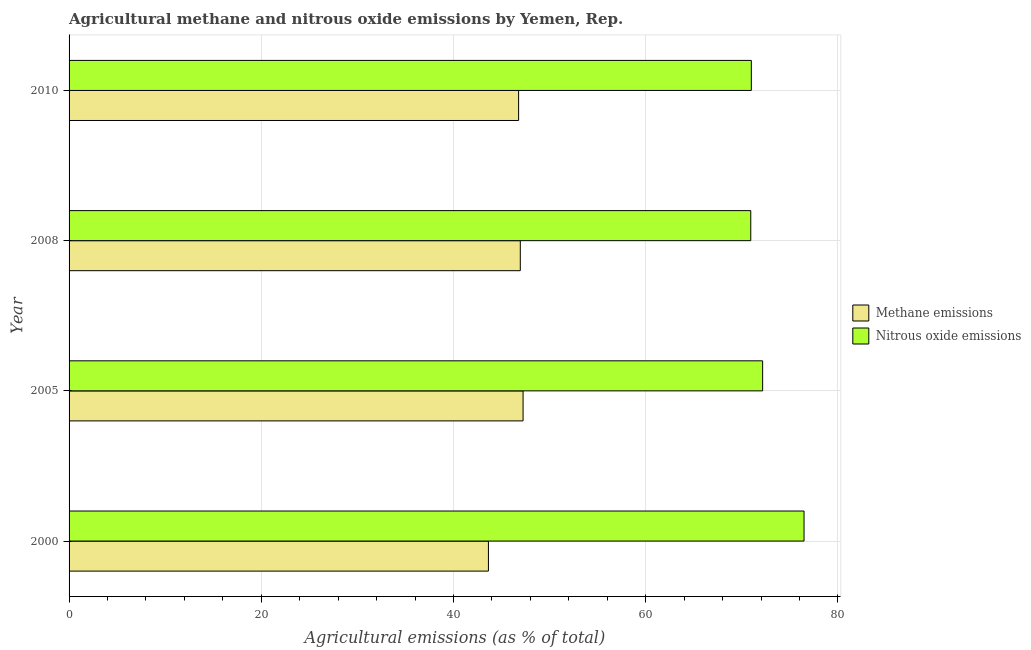How many different coloured bars are there?
Offer a very short reply. 2. Are the number of bars per tick equal to the number of legend labels?
Give a very brief answer. Yes. Are the number of bars on each tick of the Y-axis equal?
Your response must be concise. Yes. How many bars are there on the 2nd tick from the top?
Offer a very short reply. 2. What is the label of the 4th group of bars from the top?
Offer a very short reply. 2000. What is the amount of nitrous oxide emissions in 2000?
Your answer should be very brief. 76.48. Across all years, what is the maximum amount of nitrous oxide emissions?
Ensure brevity in your answer.  76.48. Across all years, what is the minimum amount of methane emissions?
Ensure brevity in your answer.  43.64. What is the total amount of nitrous oxide emissions in the graph?
Make the answer very short. 290.58. What is the difference between the amount of methane emissions in 2005 and that in 2008?
Provide a succinct answer. 0.29. What is the difference between the amount of nitrous oxide emissions in 2000 and the amount of methane emissions in 2005?
Your response must be concise. 29.24. What is the average amount of methane emissions per year?
Provide a short and direct response. 46.15. In the year 2010, what is the difference between the amount of methane emissions and amount of nitrous oxide emissions?
Your response must be concise. -24.22. What is the ratio of the amount of nitrous oxide emissions in 2000 to that in 2008?
Offer a very short reply. 1.08. Is the amount of methane emissions in 2008 less than that in 2010?
Offer a very short reply. No. Is the difference between the amount of methane emissions in 2008 and 2010 greater than the difference between the amount of nitrous oxide emissions in 2008 and 2010?
Make the answer very short. Yes. What is the difference between the highest and the second highest amount of nitrous oxide emissions?
Keep it short and to the point. 4.31. What is the difference between the highest and the lowest amount of nitrous oxide emissions?
Give a very brief answer. 5.54. What does the 2nd bar from the top in 2005 represents?
Provide a succinct answer. Methane emissions. What does the 2nd bar from the bottom in 2008 represents?
Ensure brevity in your answer.  Nitrous oxide emissions. How many bars are there?
Make the answer very short. 8. Are all the bars in the graph horizontal?
Your response must be concise. Yes. How many years are there in the graph?
Give a very brief answer. 4. Does the graph contain any zero values?
Keep it short and to the point. No. Where does the legend appear in the graph?
Provide a short and direct response. Center right. How many legend labels are there?
Offer a very short reply. 2. What is the title of the graph?
Ensure brevity in your answer.  Agricultural methane and nitrous oxide emissions by Yemen, Rep. What is the label or title of the X-axis?
Your response must be concise. Agricultural emissions (as % of total). What is the label or title of the Y-axis?
Offer a terse response. Year. What is the Agricultural emissions (as % of total) of Methane emissions in 2000?
Keep it short and to the point. 43.64. What is the Agricultural emissions (as % of total) of Nitrous oxide emissions in 2000?
Ensure brevity in your answer.  76.48. What is the Agricultural emissions (as % of total) in Methane emissions in 2005?
Provide a succinct answer. 47.24. What is the Agricultural emissions (as % of total) of Nitrous oxide emissions in 2005?
Give a very brief answer. 72.17. What is the Agricultural emissions (as % of total) of Methane emissions in 2008?
Give a very brief answer. 46.95. What is the Agricultural emissions (as % of total) of Nitrous oxide emissions in 2008?
Provide a succinct answer. 70.93. What is the Agricultural emissions (as % of total) of Methane emissions in 2010?
Ensure brevity in your answer.  46.78. What is the Agricultural emissions (as % of total) in Nitrous oxide emissions in 2010?
Provide a short and direct response. 70.99. Across all years, what is the maximum Agricultural emissions (as % of total) of Methane emissions?
Your response must be concise. 47.24. Across all years, what is the maximum Agricultural emissions (as % of total) of Nitrous oxide emissions?
Offer a very short reply. 76.48. Across all years, what is the minimum Agricultural emissions (as % of total) of Methane emissions?
Provide a succinct answer. 43.64. Across all years, what is the minimum Agricultural emissions (as % of total) of Nitrous oxide emissions?
Offer a very short reply. 70.93. What is the total Agricultural emissions (as % of total) in Methane emissions in the graph?
Keep it short and to the point. 184.61. What is the total Agricultural emissions (as % of total) of Nitrous oxide emissions in the graph?
Offer a very short reply. 290.58. What is the difference between the Agricultural emissions (as % of total) of Methane emissions in 2000 and that in 2005?
Offer a very short reply. -3.61. What is the difference between the Agricultural emissions (as % of total) in Nitrous oxide emissions in 2000 and that in 2005?
Your answer should be very brief. 4.31. What is the difference between the Agricultural emissions (as % of total) of Methane emissions in 2000 and that in 2008?
Ensure brevity in your answer.  -3.32. What is the difference between the Agricultural emissions (as % of total) of Nitrous oxide emissions in 2000 and that in 2008?
Your response must be concise. 5.54. What is the difference between the Agricultural emissions (as % of total) in Methane emissions in 2000 and that in 2010?
Your answer should be compact. -3.14. What is the difference between the Agricultural emissions (as % of total) in Nitrous oxide emissions in 2000 and that in 2010?
Ensure brevity in your answer.  5.49. What is the difference between the Agricultural emissions (as % of total) in Methane emissions in 2005 and that in 2008?
Your response must be concise. 0.29. What is the difference between the Agricultural emissions (as % of total) in Nitrous oxide emissions in 2005 and that in 2008?
Make the answer very short. 1.24. What is the difference between the Agricultural emissions (as % of total) in Methane emissions in 2005 and that in 2010?
Make the answer very short. 0.46. What is the difference between the Agricultural emissions (as % of total) in Nitrous oxide emissions in 2005 and that in 2010?
Your answer should be compact. 1.18. What is the difference between the Agricultural emissions (as % of total) of Methane emissions in 2008 and that in 2010?
Give a very brief answer. 0.18. What is the difference between the Agricultural emissions (as % of total) of Nitrous oxide emissions in 2008 and that in 2010?
Your answer should be very brief. -0.06. What is the difference between the Agricultural emissions (as % of total) in Methane emissions in 2000 and the Agricultural emissions (as % of total) in Nitrous oxide emissions in 2005?
Offer a terse response. -28.53. What is the difference between the Agricultural emissions (as % of total) in Methane emissions in 2000 and the Agricultural emissions (as % of total) in Nitrous oxide emissions in 2008?
Your response must be concise. -27.3. What is the difference between the Agricultural emissions (as % of total) of Methane emissions in 2000 and the Agricultural emissions (as % of total) of Nitrous oxide emissions in 2010?
Provide a succinct answer. -27.36. What is the difference between the Agricultural emissions (as % of total) of Methane emissions in 2005 and the Agricultural emissions (as % of total) of Nitrous oxide emissions in 2008?
Your response must be concise. -23.69. What is the difference between the Agricultural emissions (as % of total) of Methane emissions in 2005 and the Agricultural emissions (as % of total) of Nitrous oxide emissions in 2010?
Make the answer very short. -23.75. What is the difference between the Agricultural emissions (as % of total) in Methane emissions in 2008 and the Agricultural emissions (as % of total) in Nitrous oxide emissions in 2010?
Provide a short and direct response. -24.04. What is the average Agricultural emissions (as % of total) in Methane emissions per year?
Provide a short and direct response. 46.15. What is the average Agricultural emissions (as % of total) in Nitrous oxide emissions per year?
Give a very brief answer. 72.64. In the year 2000, what is the difference between the Agricultural emissions (as % of total) in Methane emissions and Agricultural emissions (as % of total) in Nitrous oxide emissions?
Provide a succinct answer. -32.84. In the year 2005, what is the difference between the Agricultural emissions (as % of total) in Methane emissions and Agricultural emissions (as % of total) in Nitrous oxide emissions?
Your answer should be compact. -24.93. In the year 2008, what is the difference between the Agricultural emissions (as % of total) of Methane emissions and Agricultural emissions (as % of total) of Nitrous oxide emissions?
Provide a short and direct response. -23.98. In the year 2010, what is the difference between the Agricultural emissions (as % of total) in Methane emissions and Agricultural emissions (as % of total) in Nitrous oxide emissions?
Your answer should be compact. -24.22. What is the ratio of the Agricultural emissions (as % of total) in Methane emissions in 2000 to that in 2005?
Provide a succinct answer. 0.92. What is the ratio of the Agricultural emissions (as % of total) in Nitrous oxide emissions in 2000 to that in 2005?
Ensure brevity in your answer.  1.06. What is the ratio of the Agricultural emissions (as % of total) in Methane emissions in 2000 to that in 2008?
Provide a short and direct response. 0.93. What is the ratio of the Agricultural emissions (as % of total) in Nitrous oxide emissions in 2000 to that in 2008?
Provide a succinct answer. 1.08. What is the ratio of the Agricultural emissions (as % of total) in Methane emissions in 2000 to that in 2010?
Give a very brief answer. 0.93. What is the ratio of the Agricultural emissions (as % of total) in Nitrous oxide emissions in 2000 to that in 2010?
Keep it short and to the point. 1.08. What is the ratio of the Agricultural emissions (as % of total) in Nitrous oxide emissions in 2005 to that in 2008?
Give a very brief answer. 1.02. What is the ratio of the Agricultural emissions (as % of total) in Methane emissions in 2005 to that in 2010?
Give a very brief answer. 1.01. What is the ratio of the Agricultural emissions (as % of total) of Nitrous oxide emissions in 2005 to that in 2010?
Provide a succinct answer. 1.02. What is the difference between the highest and the second highest Agricultural emissions (as % of total) in Methane emissions?
Offer a terse response. 0.29. What is the difference between the highest and the second highest Agricultural emissions (as % of total) of Nitrous oxide emissions?
Keep it short and to the point. 4.31. What is the difference between the highest and the lowest Agricultural emissions (as % of total) of Methane emissions?
Your response must be concise. 3.61. What is the difference between the highest and the lowest Agricultural emissions (as % of total) of Nitrous oxide emissions?
Keep it short and to the point. 5.54. 